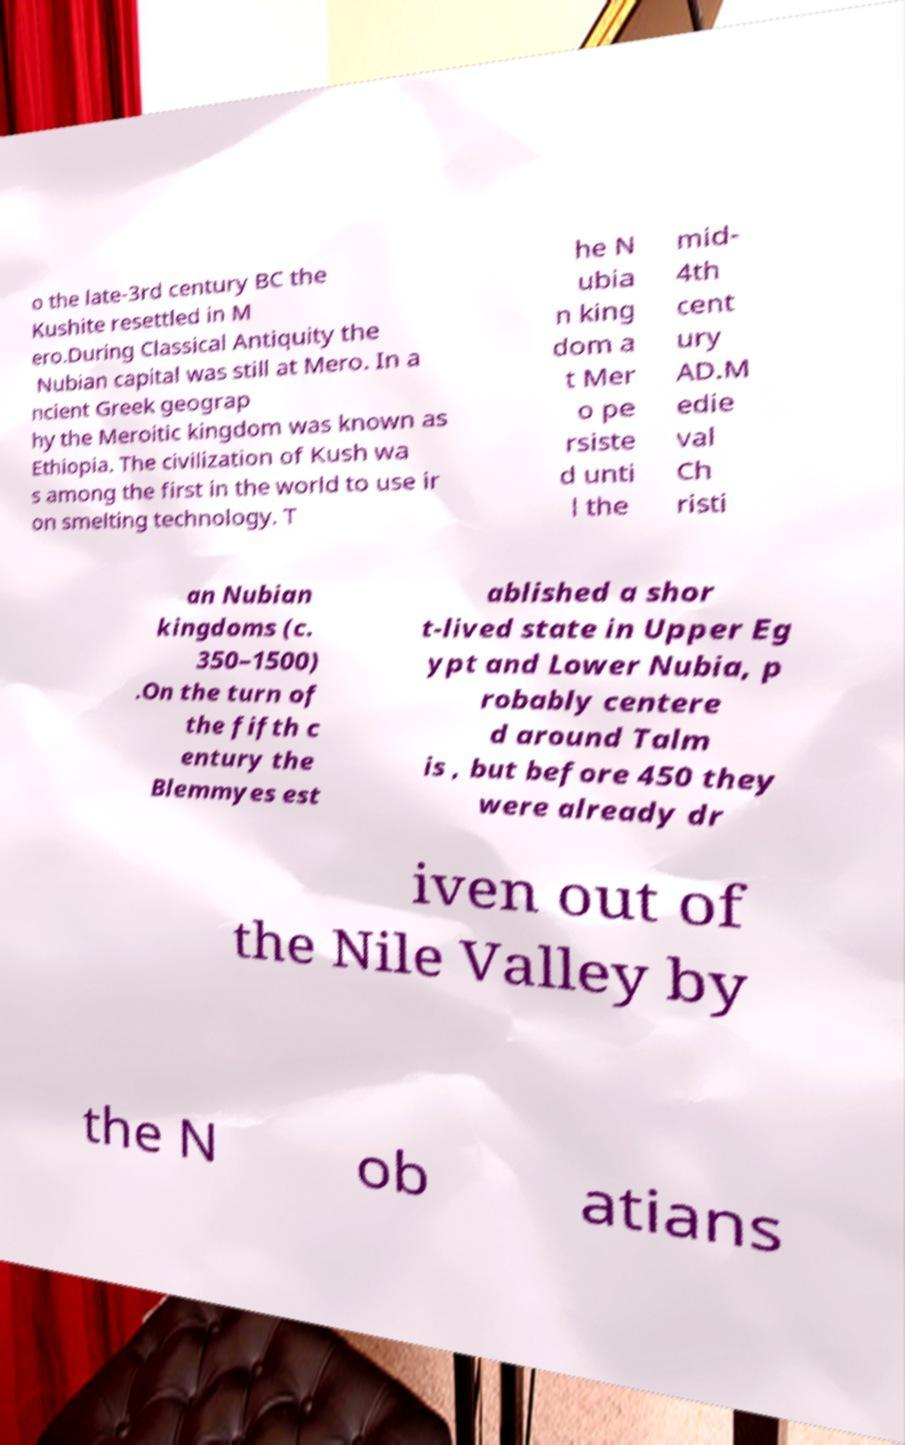Can you read and provide the text displayed in the image?This photo seems to have some interesting text. Can you extract and type it out for me? o the late-3rd century BC the Kushite resettled in M ero.During Classical Antiquity the Nubian capital was still at Mero. In a ncient Greek geograp hy the Meroitic kingdom was known as Ethiopia. The civilization of Kush wa s among the first in the world to use ir on smelting technology. T he N ubia n king dom a t Mer o pe rsiste d unti l the mid- 4th cent ury AD.M edie val Ch risti an Nubian kingdoms (c. 350–1500) .On the turn of the fifth c entury the Blemmyes est ablished a shor t-lived state in Upper Eg ypt and Lower Nubia, p robably centere d around Talm is , but before 450 they were already dr iven out of the Nile Valley by the N ob atians 